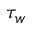Convert formula to latex. <formula><loc_0><loc_0><loc_500><loc_500>\tau _ { w }</formula> 